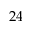<formula> <loc_0><loc_0><loc_500><loc_500>2 4</formula> 